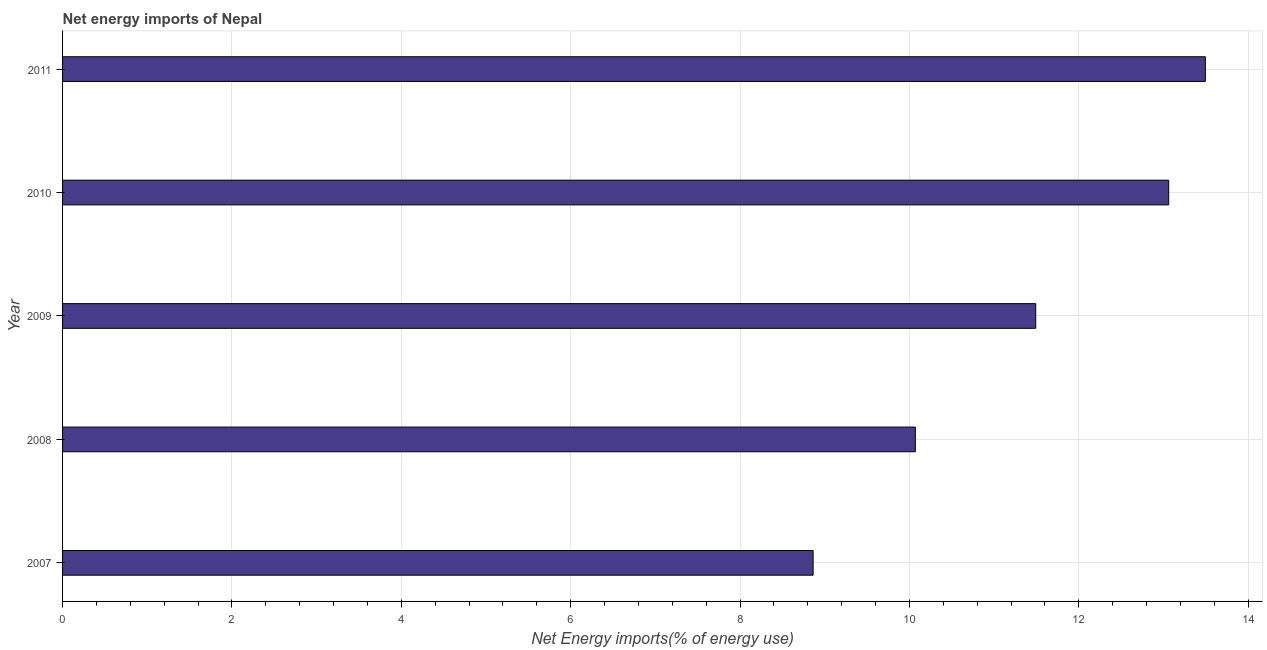Does the graph contain any zero values?
Give a very brief answer. No. What is the title of the graph?
Your response must be concise. Net energy imports of Nepal. What is the label or title of the X-axis?
Your response must be concise. Net Energy imports(% of energy use). What is the energy imports in 2011?
Provide a short and direct response. 13.49. Across all years, what is the maximum energy imports?
Your answer should be very brief. 13.49. Across all years, what is the minimum energy imports?
Give a very brief answer. 8.86. In which year was the energy imports maximum?
Provide a short and direct response. 2011. In which year was the energy imports minimum?
Make the answer very short. 2007. What is the sum of the energy imports?
Provide a short and direct response. 56.98. What is the difference between the energy imports in 2009 and 2010?
Provide a succinct answer. -1.57. What is the average energy imports per year?
Ensure brevity in your answer.  11.4. What is the median energy imports?
Ensure brevity in your answer.  11.49. Do a majority of the years between 2009 and 2011 (inclusive) have energy imports greater than 4 %?
Your answer should be very brief. Yes. What is the ratio of the energy imports in 2008 to that in 2010?
Keep it short and to the point. 0.77. What is the difference between the highest and the second highest energy imports?
Provide a short and direct response. 0.43. What is the difference between the highest and the lowest energy imports?
Provide a succinct answer. 4.63. In how many years, is the energy imports greater than the average energy imports taken over all years?
Your response must be concise. 3. How many bars are there?
Offer a very short reply. 5. Are all the bars in the graph horizontal?
Your response must be concise. Yes. How many years are there in the graph?
Keep it short and to the point. 5. What is the difference between two consecutive major ticks on the X-axis?
Give a very brief answer. 2. Are the values on the major ticks of X-axis written in scientific E-notation?
Your response must be concise. No. What is the Net Energy imports(% of energy use) of 2007?
Provide a short and direct response. 8.86. What is the Net Energy imports(% of energy use) in 2008?
Your answer should be compact. 10.07. What is the Net Energy imports(% of energy use) in 2009?
Offer a terse response. 11.49. What is the Net Energy imports(% of energy use) of 2010?
Your answer should be compact. 13.06. What is the Net Energy imports(% of energy use) in 2011?
Give a very brief answer. 13.49. What is the difference between the Net Energy imports(% of energy use) in 2007 and 2008?
Your answer should be very brief. -1.21. What is the difference between the Net Energy imports(% of energy use) in 2007 and 2009?
Provide a succinct answer. -2.63. What is the difference between the Net Energy imports(% of energy use) in 2007 and 2010?
Your response must be concise. -4.2. What is the difference between the Net Energy imports(% of energy use) in 2007 and 2011?
Ensure brevity in your answer.  -4.63. What is the difference between the Net Energy imports(% of energy use) in 2008 and 2009?
Ensure brevity in your answer.  -1.42. What is the difference between the Net Energy imports(% of energy use) in 2008 and 2010?
Provide a succinct answer. -2.99. What is the difference between the Net Energy imports(% of energy use) in 2008 and 2011?
Your response must be concise. -3.42. What is the difference between the Net Energy imports(% of energy use) in 2009 and 2010?
Ensure brevity in your answer.  -1.57. What is the difference between the Net Energy imports(% of energy use) in 2009 and 2011?
Ensure brevity in your answer.  -2. What is the difference between the Net Energy imports(% of energy use) in 2010 and 2011?
Offer a very short reply. -0.43. What is the ratio of the Net Energy imports(% of energy use) in 2007 to that in 2009?
Your response must be concise. 0.77. What is the ratio of the Net Energy imports(% of energy use) in 2007 to that in 2010?
Your answer should be very brief. 0.68. What is the ratio of the Net Energy imports(% of energy use) in 2007 to that in 2011?
Offer a terse response. 0.66. What is the ratio of the Net Energy imports(% of energy use) in 2008 to that in 2009?
Ensure brevity in your answer.  0.88. What is the ratio of the Net Energy imports(% of energy use) in 2008 to that in 2010?
Provide a short and direct response. 0.77. What is the ratio of the Net Energy imports(% of energy use) in 2008 to that in 2011?
Keep it short and to the point. 0.75. What is the ratio of the Net Energy imports(% of energy use) in 2009 to that in 2011?
Keep it short and to the point. 0.85. 